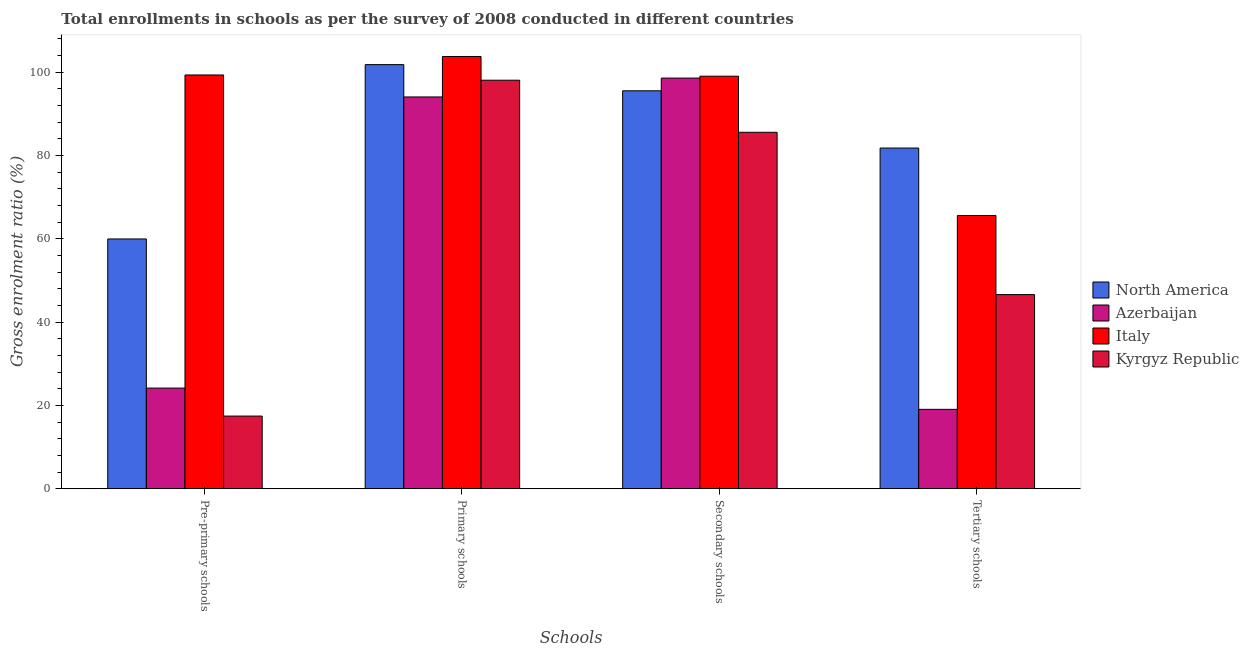How many different coloured bars are there?
Offer a terse response. 4. What is the label of the 4th group of bars from the left?
Keep it short and to the point. Tertiary schools. What is the gross enrolment ratio in pre-primary schools in North America?
Your answer should be very brief. 59.97. Across all countries, what is the maximum gross enrolment ratio in secondary schools?
Offer a terse response. 99.05. Across all countries, what is the minimum gross enrolment ratio in secondary schools?
Ensure brevity in your answer.  85.58. In which country was the gross enrolment ratio in pre-primary schools minimum?
Make the answer very short. Kyrgyz Republic. What is the total gross enrolment ratio in secondary schools in the graph?
Provide a succinct answer. 378.8. What is the difference between the gross enrolment ratio in tertiary schools in Italy and that in North America?
Provide a short and direct response. -16.2. What is the difference between the gross enrolment ratio in tertiary schools in Kyrgyz Republic and the gross enrolment ratio in pre-primary schools in North America?
Make the answer very short. -13.36. What is the average gross enrolment ratio in tertiary schools per country?
Keep it short and to the point. 53.26. What is the difference between the gross enrolment ratio in primary schools and gross enrolment ratio in secondary schools in Azerbaijan?
Provide a short and direct response. -4.53. In how many countries, is the gross enrolment ratio in secondary schools greater than 68 %?
Give a very brief answer. 4. What is the ratio of the gross enrolment ratio in tertiary schools in North America to that in Azerbaijan?
Keep it short and to the point. 4.29. What is the difference between the highest and the second highest gross enrolment ratio in pre-primary schools?
Ensure brevity in your answer.  39.38. What is the difference between the highest and the lowest gross enrolment ratio in primary schools?
Offer a very short reply. 9.72. In how many countries, is the gross enrolment ratio in pre-primary schools greater than the average gross enrolment ratio in pre-primary schools taken over all countries?
Offer a terse response. 2. Is the sum of the gross enrolment ratio in pre-primary schools in Kyrgyz Republic and North America greater than the maximum gross enrolment ratio in tertiary schools across all countries?
Your answer should be very brief. No. What does the 2nd bar from the right in Tertiary schools represents?
Make the answer very short. Italy. How many countries are there in the graph?
Give a very brief answer. 4. Are the values on the major ticks of Y-axis written in scientific E-notation?
Offer a very short reply. No. Does the graph contain grids?
Offer a very short reply. No. What is the title of the graph?
Provide a succinct answer. Total enrollments in schools as per the survey of 2008 conducted in different countries. Does "Argentina" appear as one of the legend labels in the graph?
Provide a succinct answer. No. What is the label or title of the X-axis?
Offer a very short reply. Schools. What is the label or title of the Y-axis?
Make the answer very short. Gross enrolment ratio (%). What is the Gross enrolment ratio (%) of North America in Pre-primary schools?
Your answer should be compact. 59.97. What is the Gross enrolment ratio (%) in Azerbaijan in Pre-primary schools?
Offer a very short reply. 24.16. What is the Gross enrolment ratio (%) in Italy in Pre-primary schools?
Provide a short and direct response. 99.35. What is the Gross enrolment ratio (%) of Kyrgyz Republic in Pre-primary schools?
Your answer should be very brief. 17.44. What is the Gross enrolment ratio (%) of North America in Primary schools?
Make the answer very short. 101.84. What is the Gross enrolment ratio (%) in Azerbaijan in Primary schools?
Keep it short and to the point. 94.07. What is the Gross enrolment ratio (%) in Italy in Primary schools?
Keep it short and to the point. 103.79. What is the Gross enrolment ratio (%) in Kyrgyz Republic in Primary schools?
Offer a terse response. 98.09. What is the Gross enrolment ratio (%) of North America in Secondary schools?
Provide a short and direct response. 95.55. What is the Gross enrolment ratio (%) in Azerbaijan in Secondary schools?
Ensure brevity in your answer.  98.61. What is the Gross enrolment ratio (%) in Italy in Secondary schools?
Provide a short and direct response. 99.05. What is the Gross enrolment ratio (%) in Kyrgyz Republic in Secondary schools?
Your response must be concise. 85.58. What is the Gross enrolment ratio (%) in North America in Tertiary schools?
Your answer should be compact. 81.8. What is the Gross enrolment ratio (%) of Azerbaijan in Tertiary schools?
Your answer should be very brief. 19.05. What is the Gross enrolment ratio (%) in Italy in Tertiary schools?
Your answer should be compact. 65.6. What is the Gross enrolment ratio (%) in Kyrgyz Republic in Tertiary schools?
Provide a succinct answer. 46.6. Across all Schools, what is the maximum Gross enrolment ratio (%) in North America?
Your answer should be compact. 101.84. Across all Schools, what is the maximum Gross enrolment ratio (%) of Azerbaijan?
Your answer should be compact. 98.61. Across all Schools, what is the maximum Gross enrolment ratio (%) in Italy?
Give a very brief answer. 103.79. Across all Schools, what is the maximum Gross enrolment ratio (%) of Kyrgyz Republic?
Your response must be concise. 98.09. Across all Schools, what is the minimum Gross enrolment ratio (%) of North America?
Keep it short and to the point. 59.97. Across all Schools, what is the minimum Gross enrolment ratio (%) of Azerbaijan?
Your answer should be compact. 19.05. Across all Schools, what is the minimum Gross enrolment ratio (%) in Italy?
Provide a short and direct response. 65.6. Across all Schools, what is the minimum Gross enrolment ratio (%) of Kyrgyz Republic?
Provide a succinct answer. 17.44. What is the total Gross enrolment ratio (%) in North America in the graph?
Your answer should be very brief. 339.16. What is the total Gross enrolment ratio (%) in Azerbaijan in the graph?
Give a very brief answer. 235.89. What is the total Gross enrolment ratio (%) in Italy in the graph?
Your answer should be very brief. 367.79. What is the total Gross enrolment ratio (%) of Kyrgyz Republic in the graph?
Your response must be concise. 247.72. What is the difference between the Gross enrolment ratio (%) of North America in Pre-primary schools and that in Primary schools?
Your answer should be compact. -41.87. What is the difference between the Gross enrolment ratio (%) in Azerbaijan in Pre-primary schools and that in Primary schools?
Your answer should be compact. -69.91. What is the difference between the Gross enrolment ratio (%) in Italy in Pre-primary schools and that in Primary schools?
Give a very brief answer. -4.44. What is the difference between the Gross enrolment ratio (%) of Kyrgyz Republic in Pre-primary schools and that in Primary schools?
Offer a very short reply. -80.65. What is the difference between the Gross enrolment ratio (%) in North America in Pre-primary schools and that in Secondary schools?
Offer a terse response. -35.58. What is the difference between the Gross enrolment ratio (%) in Azerbaijan in Pre-primary schools and that in Secondary schools?
Offer a terse response. -74.45. What is the difference between the Gross enrolment ratio (%) in Italy in Pre-primary schools and that in Secondary schools?
Your response must be concise. 0.29. What is the difference between the Gross enrolment ratio (%) of Kyrgyz Republic in Pre-primary schools and that in Secondary schools?
Provide a short and direct response. -68.15. What is the difference between the Gross enrolment ratio (%) of North America in Pre-primary schools and that in Tertiary schools?
Keep it short and to the point. -21.84. What is the difference between the Gross enrolment ratio (%) in Azerbaijan in Pre-primary schools and that in Tertiary schools?
Your answer should be compact. 5.11. What is the difference between the Gross enrolment ratio (%) of Italy in Pre-primary schools and that in Tertiary schools?
Offer a terse response. 33.75. What is the difference between the Gross enrolment ratio (%) of Kyrgyz Republic in Pre-primary schools and that in Tertiary schools?
Your answer should be very brief. -29.17. What is the difference between the Gross enrolment ratio (%) of North America in Primary schools and that in Secondary schools?
Your answer should be very brief. 6.29. What is the difference between the Gross enrolment ratio (%) of Azerbaijan in Primary schools and that in Secondary schools?
Keep it short and to the point. -4.53. What is the difference between the Gross enrolment ratio (%) in Italy in Primary schools and that in Secondary schools?
Keep it short and to the point. 4.73. What is the difference between the Gross enrolment ratio (%) of Kyrgyz Republic in Primary schools and that in Secondary schools?
Offer a very short reply. 12.51. What is the difference between the Gross enrolment ratio (%) in North America in Primary schools and that in Tertiary schools?
Give a very brief answer. 20.03. What is the difference between the Gross enrolment ratio (%) in Azerbaijan in Primary schools and that in Tertiary schools?
Provide a short and direct response. 75.02. What is the difference between the Gross enrolment ratio (%) in Italy in Primary schools and that in Tertiary schools?
Offer a very short reply. 38.19. What is the difference between the Gross enrolment ratio (%) of Kyrgyz Republic in Primary schools and that in Tertiary schools?
Provide a short and direct response. 51.49. What is the difference between the Gross enrolment ratio (%) in North America in Secondary schools and that in Tertiary schools?
Your answer should be compact. 13.75. What is the difference between the Gross enrolment ratio (%) of Azerbaijan in Secondary schools and that in Tertiary schools?
Keep it short and to the point. 79.56. What is the difference between the Gross enrolment ratio (%) of Italy in Secondary schools and that in Tertiary schools?
Ensure brevity in your answer.  33.45. What is the difference between the Gross enrolment ratio (%) of Kyrgyz Republic in Secondary schools and that in Tertiary schools?
Your response must be concise. 38.98. What is the difference between the Gross enrolment ratio (%) of North America in Pre-primary schools and the Gross enrolment ratio (%) of Azerbaijan in Primary schools?
Keep it short and to the point. -34.1. What is the difference between the Gross enrolment ratio (%) of North America in Pre-primary schools and the Gross enrolment ratio (%) of Italy in Primary schools?
Ensure brevity in your answer.  -43.82. What is the difference between the Gross enrolment ratio (%) in North America in Pre-primary schools and the Gross enrolment ratio (%) in Kyrgyz Republic in Primary schools?
Keep it short and to the point. -38.12. What is the difference between the Gross enrolment ratio (%) of Azerbaijan in Pre-primary schools and the Gross enrolment ratio (%) of Italy in Primary schools?
Keep it short and to the point. -79.63. What is the difference between the Gross enrolment ratio (%) in Azerbaijan in Pre-primary schools and the Gross enrolment ratio (%) in Kyrgyz Republic in Primary schools?
Give a very brief answer. -73.93. What is the difference between the Gross enrolment ratio (%) of Italy in Pre-primary schools and the Gross enrolment ratio (%) of Kyrgyz Republic in Primary schools?
Your answer should be compact. 1.26. What is the difference between the Gross enrolment ratio (%) in North America in Pre-primary schools and the Gross enrolment ratio (%) in Azerbaijan in Secondary schools?
Offer a very short reply. -38.64. What is the difference between the Gross enrolment ratio (%) in North America in Pre-primary schools and the Gross enrolment ratio (%) in Italy in Secondary schools?
Offer a terse response. -39.09. What is the difference between the Gross enrolment ratio (%) in North America in Pre-primary schools and the Gross enrolment ratio (%) in Kyrgyz Republic in Secondary schools?
Your response must be concise. -25.62. What is the difference between the Gross enrolment ratio (%) in Azerbaijan in Pre-primary schools and the Gross enrolment ratio (%) in Italy in Secondary schools?
Provide a short and direct response. -74.89. What is the difference between the Gross enrolment ratio (%) of Azerbaijan in Pre-primary schools and the Gross enrolment ratio (%) of Kyrgyz Republic in Secondary schools?
Offer a very short reply. -61.42. What is the difference between the Gross enrolment ratio (%) of Italy in Pre-primary schools and the Gross enrolment ratio (%) of Kyrgyz Republic in Secondary schools?
Keep it short and to the point. 13.76. What is the difference between the Gross enrolment ratio (%) of North America in Pre-primary schools and the Gross enrolment ratio (%) of Azerbaijan in Tertiary schools?
Give a very brief answer. 40.92. What is the difference between the Gross enrolment ratio (%) in North America in Pre-primary schools and the Gross enrolment ratio (%) in Italy in Tertiary schools?
Give a very brief answer. -5.63. What is the difference between the Gross enrolment ratio (%) in North America in Pre-primary schools and the Gross enrolment ratio (%) in Kyrgyz Republic in Tertiary schools?
Offer a terse response. 13.36. What is the difference between the Gross enrolment ratio (%) of Azerbaijan in Pre-primary schools and the Gross enrolment ratio (%) of Italy in Tertiary schools?
Keep it short and to the point. -41.44. What is the difference between the Gross enrolment ratio (%) in Azerbaijan in Pre-primary schools and the Gross enrolment ratio (%) in Kyrgyz Republic in Tertiary schools?
Your response must be concise. -22.44. What is the difference between the Gross enrolment ratio (%) in Italy in Pre-primary schools and the Gross enrolment ratio (%) in Kyrgyz Republic in Tertiary schools?
Offer a very short reply. 52.74. What is the difference between the Gross enrolment ratio (%) of North America in Primary schools and the Gross enrolment ratio (%) of Azerbaijan in Secondary schools?
Provide a short and direct response. 3.23. What is the difference between the Gross enrolment ratio (%) of North America in Primary schools and the Gross enrolment ratio (%) of Italy in Secondary schools?
Provide a short and direct response. 2.78. What is the difference between the Gross enrolment ratio (%) in North America in Primary schools and the Gross enrolment ratio (%) in Kyrgyz Republic in Secondary schools?
Offer a very short reply. 16.25. What is the difference between the Gross enrolment ratio (%) in Azerbaijan in Primary schools and the Gross enrolment ratio (%) in Italy in Secondary schools?
Give a very brief answer. -4.98. What is the difference between the Gross enrolment ratio (%) of Azerbaijan in Primary schools and the Gross enrolment ratio (%) of Kyrgyz Republic in Secondary schools?
Offer a very short reply. 8.49. What is the difference between the Gross enrolment ratio (%) in Italy in Primary schools and the Gross enrolment ratio (%) in Kyrgyz Republic in Secondary schools?
Offer a terse response. 18.2. What is the difference between the Gross enrolment ratio (%) of North America in Primary schools and the Gross enrolment ratio (%) of Azerbaijan in Tertiary schools?
Provide a short and direct response. 82.79. What is the difference between the Gross enrolment ratio (%) of North America in Primary schools and the Gross enrolment ratio (%) of Italy in Tertiary schools?
Your answer should be compact. 36.23. What is the difference between the Gross enrolment ratio (%) of North America in Primary schools and the Gross enrolment ratio (%) of Kyrgyz Republic in Tertiary schools?
Your answer should be compact. 55.23. What is the difference between the Gross enrolment ratio (%) in Azerbaijan in Primary schools and the Gross enrolment ratio (%) in Italy in Tertiary schools?
Your answer should be compact. 28.47. What is the difference between the Gross enrolment ratio (%) of Azerbaijan in Primary schools and the Gross enrolment ratio (%) of Kyrgyz Republic in Tertiary schools?
Provide a short and direct response. 47.47. What is the difference between the Gross enrolment ratio (%) in Italy in Primary schools and the Gross enrolment ratio (%) in Kyrgyz Republic in Tertiary schools?
Your answer should be compact. 57.18. What is the difference between the Gross enrolment ratio (%) in North America in Secondary schools and the Gross enrolment ratio (%) in Azerbaijan in Tertiary schools?
Keep it short and to the point. 76.5. What is the difference between the Gross enrolment ratio (%) in North America in Secondary schools and the Gross enrolment ratio (%) in Italy in Tertiary schools?
Your response must be concise. 29.95. What is the difference between the Gross enrolment ratio (%) in North America in Secondary schools and the Gross enrolment ratio (%) in Kyrgyz Republic in Tertiary schools?
Offer a very short reply. 48.95. What is the difference between the Gross enrolment ratio (%) of Azerbaijan in Secondary schools and the Gross enrolment ratio (%) of Italy in Tertiary schools?
Give a very brief answer. 33. What is the difference between the Gross enrolment ratio (%) in Azerbaijan in Secondary schools and the Gross enrolment ratio (%) in Kyrgyz Republic in Tertiary schools?
Ensure brevity in your answer.  52. What is the difference between the Gross enrolment ratio (%) of Italy in Secondary schools and the Gross enrolment ratio (%) of Kyrgyz Republic in Tertiary schools?
Keep it short and to the point. 52.45. What is the average Gross enrolment ratio (%) of North America per Schools?
Ensure brevity in your answer.  84.79. What is the average Gross enrolment ratio (%) of Azerbaijan per Schools?
Ensure brevity in your answer.  58.97. What is the average Gross enrolment ratio (%) of Italy per Schools?
Your answer should be very brief. 91.95. What is the average Gross enrolment ratio (%) in Kyrgyz Republic per Schools?
Offer a very short reply. 61.93. What is the difference between the Gross enrolment ratio (%) in North America and Gross enrolment ratio (%) in Azerbaijan in Pre-primary schools?
Make the answer very short. 35.81. What is the difference between the Gross enrolment ratio (%) of North America and Gross enrolment ratio (%) of Italy in Pre-primary schools?
Your response must be concise. -39.38. What is the difference between the Gross enrolment ratio (%) in North America and Gross enrolment ratio (%) in Kyrgyz Republic in Pre-primary schools?
Your answer should be compact. 42.53. What is the difference between the Gross enrolment ratio (%) of Azerbaijan and Gross enrolment ratio (%) of Italy in Pre-primary schools?
Keep it short and to the point. -75.19. What is the difference between the Gross enrolment ratio (%) in Azerbaijan and Gross enrolment ratio (%) in Kyrgyz Republic in Pre-primary schools?
Ensure brevity in your answer.  6.72. What is the difference between the Gross enrolment ratio (%) of Italy and Gross enrolment ratio (%) of Kyrgyz Republic in Pre-primary schools?
Give a very brief answer. 81.91. What is the difference between the Gross enrolment ratio (%) of North America and Gross enrolment ratio (%) of Azerbaijan in Primary schools?
Your answer should be very brief. 7.76. What is the difference between the Gross enrolment ratio (%) in North America and Gross enrolment ratio (%) in Italy in Primary schools?
Make the answer very short. -1.95. What is the difference between the Gross enrolment ratio (%) in North America and Gross enrolment ratio (%) in Kyrgyz Republic in Primary schools?
Ensure brevity in your answer.  3.74. What is the difference between the Gross enrolment ratio (%) of Azerbaijan and Gross enrolment ratio (%) of Italy in Primary schools?
Provide a short and direct response. -9.72. What is the difference between the Gross enrolment ratio (%) in Azerbaijan and Gross enrolment ratio (%) in Kyrgyz Republic in Primary schools?
Provide a succinct answer. -4.02. What is the difference between the Gross enrolment ratio (%) of Italy and Gross enrolment ratio (%) of Kyrgyz Republic in Primary schools?
Your answer should be compact. 5.7. What is the difference between the Gross enrolment ratio (%) in North America and Gross enrolment ratio (%) in Azerbaijan in Secondary schools?
Ensure brevity in your answer.  -3.05. What is the difference between the Gross enrolment ratio (%) in North America and Gross enrolment ratio (%) in Italy in Secondary schools?
Offer a terse response. -3.5. What is the difference between the Gross enrolment ratio (%) of North America and Gross enrolment ratio (%) of Kyrgyz Republic in Secondary schools?
Ensure brevity in your answer.  9.97. What is the difference between the Gross enrolment ratio (%) of Azerbaijan and Gross enrolment ratio (%) of Italy in Secondary schools?
Give a very brief answer. -0.45. What is the difference between the Gross enrolment ratio (%) of Azerbaijan and Gross enrolment ratio (%) of Kyrgyz Republic in Secondary schools?
Offer a very short reply. 13.02. What is the difference between the Gross enrolment ratio (%) of Italy and Gross enrolment ratio (%) of Kyrgyz Republic in Secondary schools?
Make the answer very short. 13.47. What is the difference between the Gross enrolment ratio (%) in North America and Gross enrolment ratio (%) in Azerbaijan in Tertiary schools?
Offer a terse response. 62.76. What is the difference between the Gross enrolment ratio (%) of North America and Gross enrolment ratio (%) of Italy in Tertiary schools?
Your answer should be compact. 16.2. What is the difference between the Gross enrolment ratio (%) of North America and Gross enrolment ratio (%) of Kyrgyz Republic in Tertiary schools?
Keep it short and to the point. 35.2. What is the difference between the Gross enrolment ratio (%) of Azerbaijan and Gross enrolment ratio (%) of Italy in Tertiary schools?
Keep it short and to the point. -46.55. What is the difference between the Gross enrolment ratio (%) in Azerbaijan and Gross enrolment ratio (%) in Kyrgyz Republic in Tertiary schools?
Your answer should be compact. -27.56. What is the difference between the Gross enrolment ratio (%) of Italy and Gross enrolment ratio (%) of Kyrgyz Republic in Tertiary schools?
Give a very brief answer. 19. What is the ratio of the Gross enrolment ratio (%) in North America in Pre-primary schools to that in Primary schools?
Provide a short and direct response. 0.59. What is the ratio of the Gross enrolment ratio (%) of Azerbaijan in Pre-primary schools to that in Primary schools?
Make the answer very short. 0.26. What is the ratio of the Gross enrolment ratio (%) of Italy in Pre-primary schools to that in Primary schools?
Your answer should be very brief. 0.96. What is the ratio of the Gross enrolment ratio (%) of Kyrgyz Republic in Pre-primary schools to that in Primary schools?
Provide a succinct answer. 0.18. What is the ratio of the Gross enrolment ratio (%) of North America in Pre-primary schools to that in Secondary schools?
Offer a terse response. 0.63. What is the ratio of the Gross enrolment ratio (%) in Azerbaijan in Pre-primary schools to that in Secondary schools?
Give a very brief answer. 0.24. What is the ratio of the Gross enrolment ratio (%) of Kyrgyz Republic in Pre-primary schools to that in Secondary schools?
Ensure brevity in your answer.  0.2. What is the ratio of the Gross enrolment ratio (%) of North America in Pre-primary schools to that in Tertiary schools?
Make the answer very short. 0.73. What is the ratio of the Gross enrolment ratio (%) in Azerbaijan in Pre-primary schools to that in Tertiary schools?
Keep it short and to the point. 1.27. What is the ratio of the Gross enrolment ratio (%) of Italy in Pre-primary schools to that in Tertiary schools?
Offer a very short reply. 1.51. What is the ratio of the Gross enrolment ratio (%) in Kyrgyz Republic in Pre-primary schools to that in Tertiary schools?
Provide a short and direct response. 0.37. What is the ratio of the Gross enrolment ratio (%) of North America in Primary schools to that in Secondary schools?
Make the answer very short. 1.07. What is the ratio of the Gross enrolment ratio (%) of Azerbaijan in Primary schools to that in Secondary schools?
Your answer should be very brief. 0.95. What is the ratio of the Gross enrolment ratio (%) of Italy in Primary schools to that in Secondary schools?
Your response must be concise. 1.05. What is the ratio of the Gross enrolment ratio (%) of Kyrgyz Republic in Primary schools to that in Secondary schools?
Offer a very short reply. 1.15. What is the ratio of the Gross enrolment ratio (%) in North America in Primary schools to that in Tertiary schools?
Give a very brief answer. 1.24. What is the ratio of the Gross enrolment ratio (%) of Azerbaijan in Primary schools to that in Tertiary schools?
Offer a terse response. 4.94. What is the ratio of the Gross enrolment ratio (%) of Italy in Primary schools to that in Tertiary schools?
Keep it short and to the point. 1.58. What is the ratio of the Gross enrolment ratio (%) of Kyrgyz Republic in Primary schools to that in Tertiary schools?
Ensure brevity in your answer.  2.1. What is the ratio of the Gross enrolment ratio (%) in North America in Secondary schools to that in Tertiary schools?
Your answer should be very brief. 1.17. What is the ratio of the Gross enrolment ratio (%) of Azerbaijan in Secondary schools to that in Tertiary schools?
Ensure brevity in your answer.  5.18. What is the ratio of the Gross enrolment ratio (%) of Italy in Secondary schools to that in Tertiary schools?
Offer a very short reply. 1.51. What is the ratio of the Gross enrolment ratio (%) in Kyrgyz Republic in Secondary schools to that in Tertiary schools?
Your answer should be compact. 1.84. What is the difference between the highest and the second highest Gross enrolment ratio (%) in North America?
Offer a terse response. 6.29. What is the difference between the highest and the second highest Gross enrolment ratio (%) in Azerbaijan?
Keep it short and to the point. 4.53. What is the difference between the highest and the second highest Gross enrolment ratio (%) of Italy?
Give a very brief answer. 4.44. What is the difference between the highest and the second highest Gross enrolment ratio (%) in Kyrgyz Republic?
Keep it short and to the point. 12.51. What is the difference between the highest and the lowest Gross enrolment ratio (%) of North America?
Make the answer very short. 41.87. What is the difference between the highest and the lowest Gross enrolment ratio (%) in Azerbaijan?
Your answer should be very brief. 79.56. What is the difference between the highest and the lowest Gross enrolment ratio (%) of Italy?
Provide a succinct answer. 38.19. What is the difference between the highest and the lowest Gross enrolment ratio (%) in Kyrgyz Republic?
Keep it short and to the point. 80.65. 